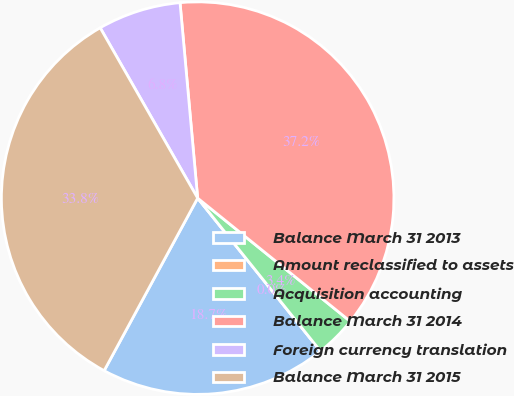Convert chart to OTSL. <chart><loc_0><loc_0><loc_500><loc_500><pie_chart><fcel>Balance March 31 2013<fcel>Amount reclassified to assets<fcel>Acquisition accounting<fcel>Balance March 31 2014<fcel>Foreign currency translation<fcel>Balance March 31 2015<nl><fcel>18.67%<fcel>0.0%<fcel>3.42%<fcel>37.24%<fcel>6.84%<fcel>33.82%<nl></chart> 